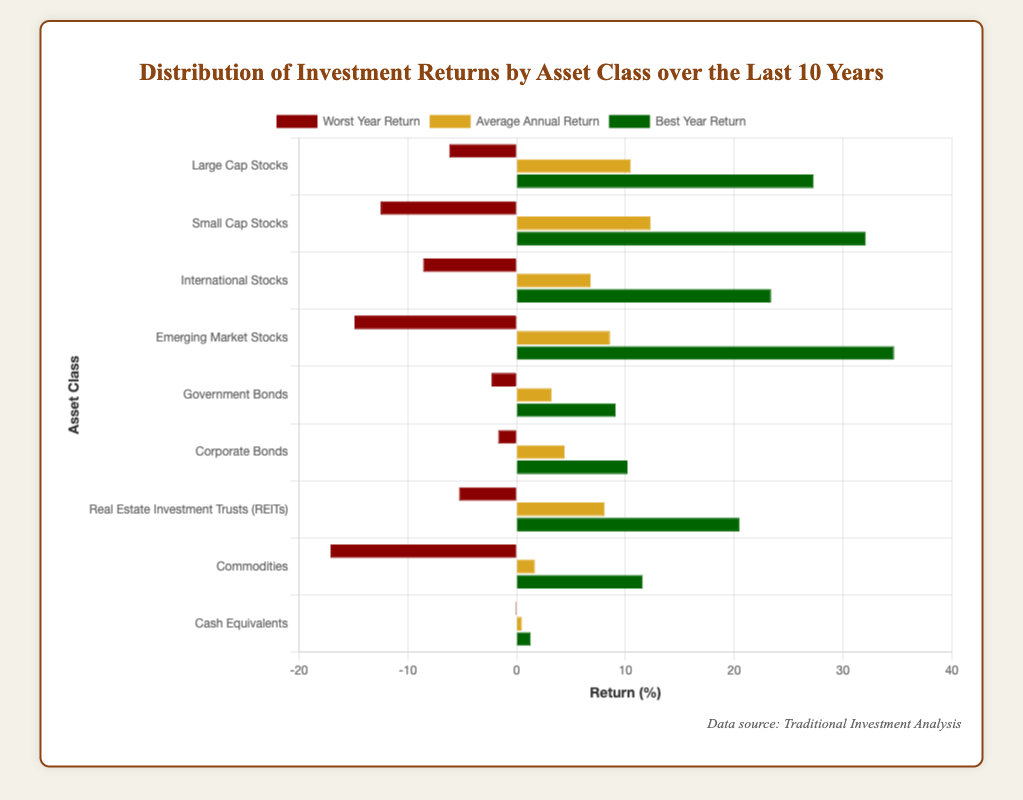What asset class has the highest average annual return? The chart shows the average annual return for each asset class as bars. The bar for Small Cap Stocks is the longest for average annual return.
Answer: Small Cap Stocks What are the differences between the best and worst year returns for Emerging Market Stocks? The best year return for Emerging Market Stocks is 34.7%, and the worst year return is -14.9%. The difference is 34.7 - (-14.9) = 49.6%.
Answer: 49.6% Which asset class has the worst performance during its worst year? To find the asset class with the worst worst-year performance, look at the 'Worst Year Return' bars. Commodities have the lowest value at -17.1%.
Answer: Commodities Compare the average annual returns of Large Cap Stocks and Corporate Bonds. The bar for Large Cap Stocks' average annual return is at 10.5%, and for Corporate Bonds, it is 4.4%. Therefore, Large Cap Stocks have a higher average annual return.
Answer: Large Cap Stocks Which asset class has a better best-year return, International Stocks or Real Estate Investment Trusts (REITs)? Look at the 'Best Year Return' bars for International Stocks and REITs. International Stocks have a best year return of 23.4%, while REITs have 20.5%. Thus, International Stocks perform better.
Answer: International Stocks Find the average of the worst-year returns for Commodities and Government Bonds. The worst year returns for Commodities and Government Bonds are -17.1% and -2.3%, respectively. The average is (-17.1 + (-2.3)) / 2 = -9.7%.
Answer: -9.7% How does the best year return of Small Cap Stocks compare to that of Large Cap Stocks? The best year return bars for Small Cap Stocks and Large Cap Stocks show values of 32.1% and 27.3%, respectively. Small Cap Stocks have a higher best year return.
Answer: Small Cap Stocks What's the range of returns (difference between best and worst year) for Cash Equivalents? The best year return for Cash Equivalents is 1.3% and the worst year return is -0.1%. The range is 1.3 - (-0.1) = 1.4%.
Answer: 1.4% What asset class offers the highest range of returns between the best and worst years? Identify the range for each asset class and compare. Emerging Market Stocks have the highest range, from -14.9% to 34.7%, which is 49.6%.
Answer: Emerging Market Stocks 